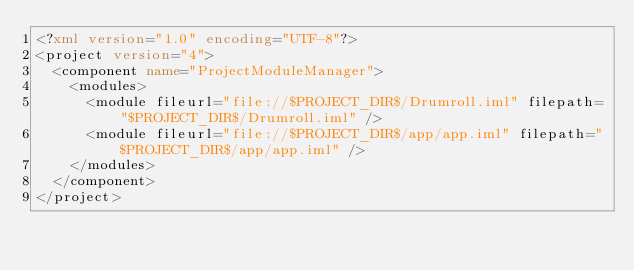Convert code to text. <code><loc_0><loc_0><loc_500><loc_500><_XML_><?xml version="1.0" encoding="UTF-8"?>
<project version="4">
  <component name="ProjectModuleManager">
    <modules>
      <module fileurl="file://$PROJECT_DIR$/Drumroll.iml" filepath="$PROJECT_DIR$/Drumroll.iml" />
      <module fileurl="file://$PROJECT_DIR$/app/app.iml" filepath="$PROJECT_DIR$/app/app.iml" />
    </modules>
  </component>
</project></code> 